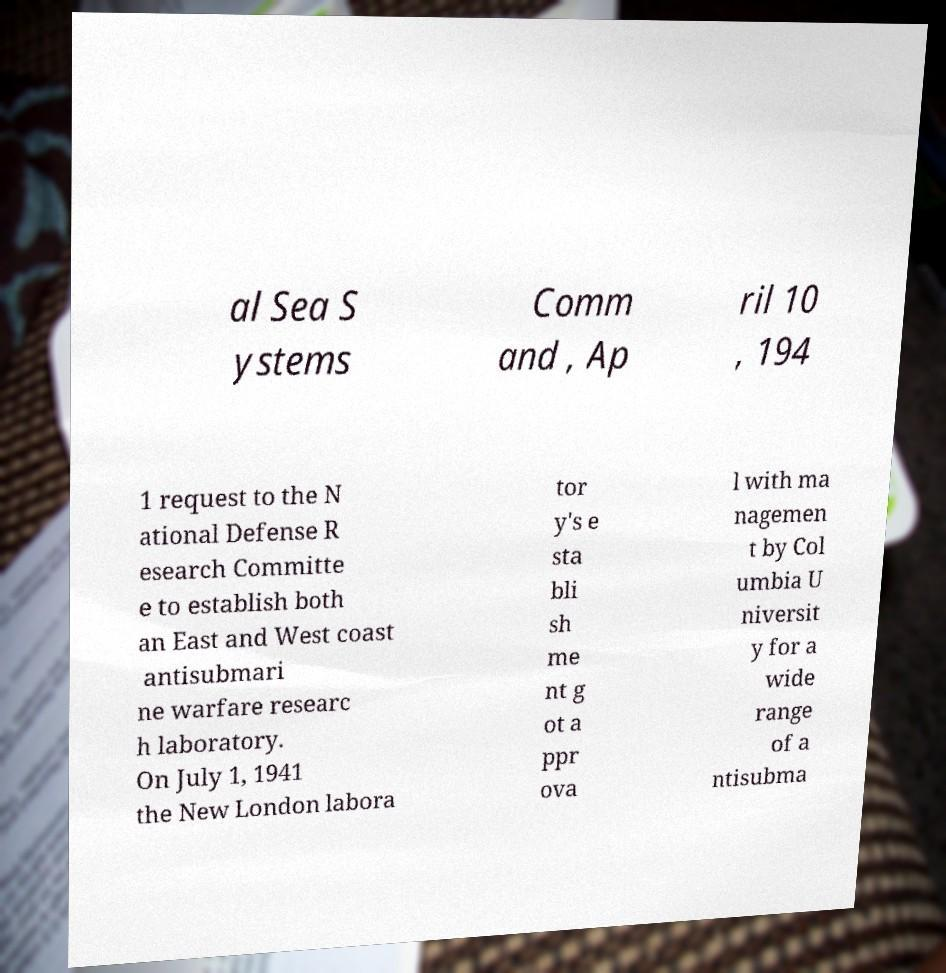Could you assist in decoding the text presented in this image and type it out clearly? al Sea S ystems Comm and , Ap ril 10 , 194 1 request to the N ational Defense R esearch Committe e to establish both an East and West coast antisubmari ne warfare researc h laboratory. On July 1, 1941 the New London labora tor y's e sta bli sh me nt g ot a ppr ova l with ma nagemen t by Col umbia U niversit y for a wide range of a ntisubma 